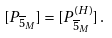Convert formula to latex. <formula><loc_0><loc_0><loc_500><loc_500>[ P _ { \overline { 5 } _ { M } } ] = [ P _ { \overline { 5 } _ { M } } ^ { ( H ) } ] \, .</formula> 